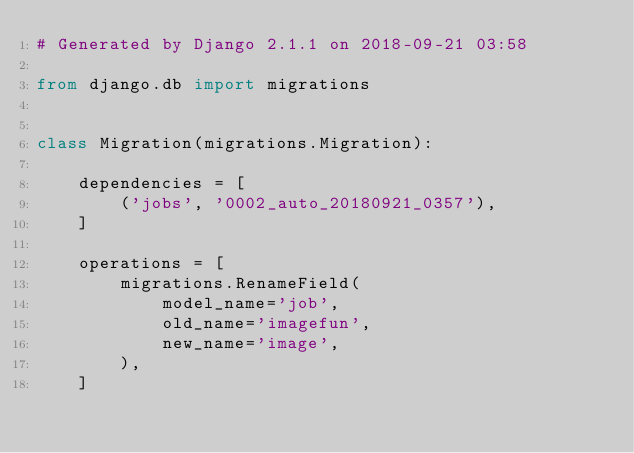Convert code to text. <code><loc_0><loc_0><loc_500><loc_500><_Python_># Generated by Django 2.1.1 on 2018-09-21 03:58

from django.db import migrations


class Migration(migrations.Migration):

    dependencies = [
        ('jobs', '0002_auto_20180921_0357'),
    ]

    operations = [
        migrations.RenameField(
            model_name='job',
            old_name='imagefun',
            new_name='image',
        ),
    ]
</code> 